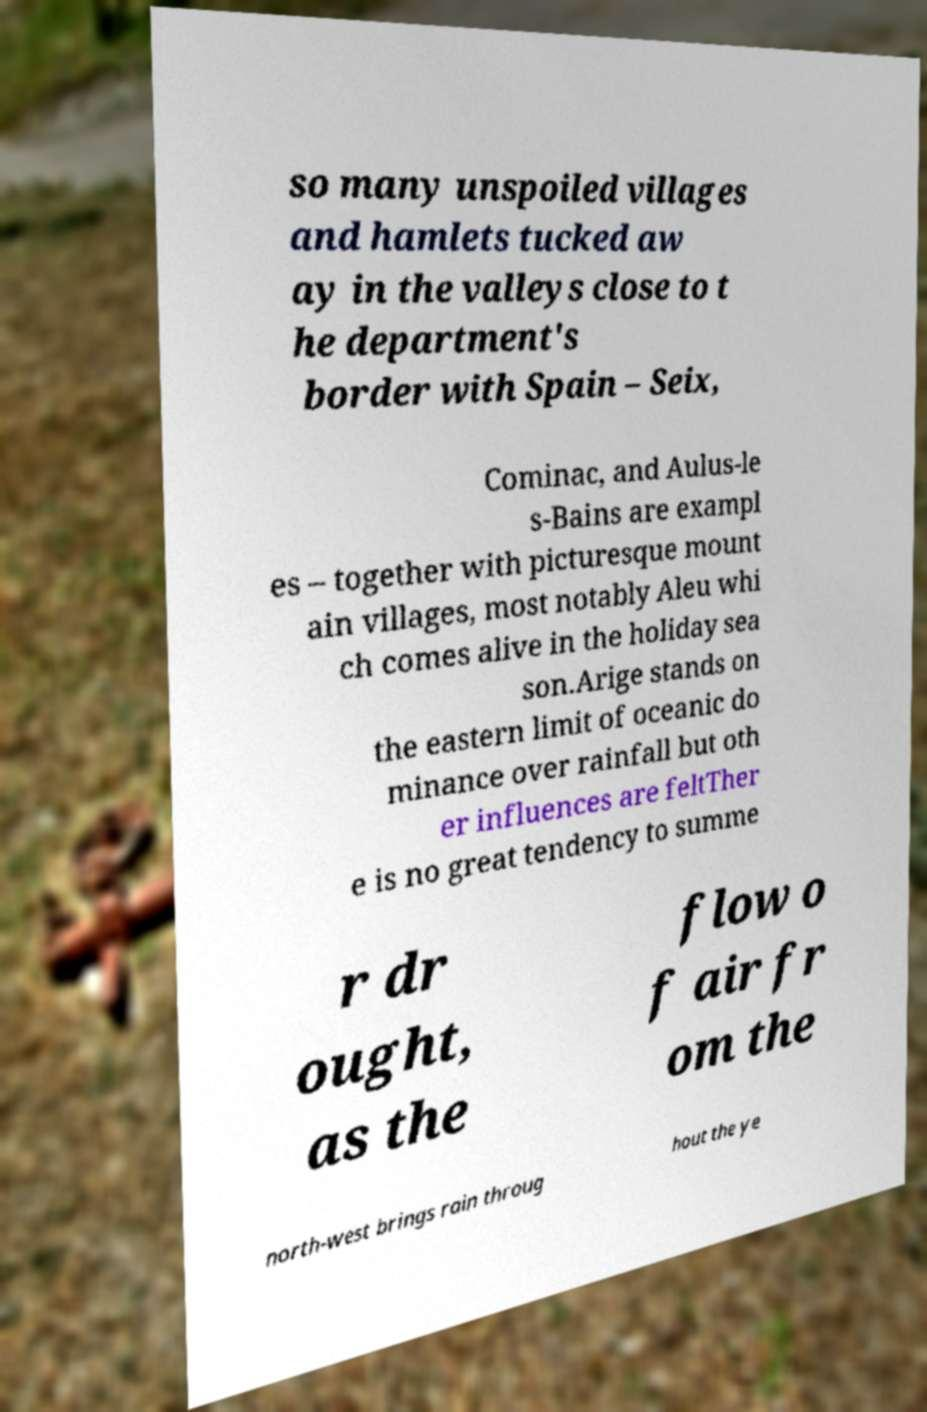Can you read and provide the text displayed in the image?This photo seems to have some interesting text. Can you extract and type it out for me? so many unspoiled villages and hamlets tucked aw ay in the valleys close to t he department's border with Spain – Seix, Cominac, and Aulus-le s-Bains are exampl es – together with picturesque mount ain villages, most notably Aleu whi ch comes alive in the holiday sea son.Arige stands on the eastern limit of oceanic do minance over rainfall but oth er influences are feltTher e is no great tendency to summe r dr ought, as the flow o f air fr om the north-west brings rain throug hout the ye 